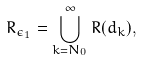<formula> <loc_0><loc_0><loc_500><loc_500>R _ { \epsilon _ { 1 } } = \bigcup _ { k = N _ { 0 } } ^ { \infty } R ( d _ { k } ) ,</formula> 